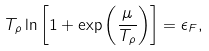<formula> <loc_0><loc_0><loc_500><loc_500>T _ { \rho } \ln { \left [ 1 + \exp { \left ( \frac { \mu } { T _ { \rho } } \right ) } \right ] } = \epsilon _ { F } ,</formula> 